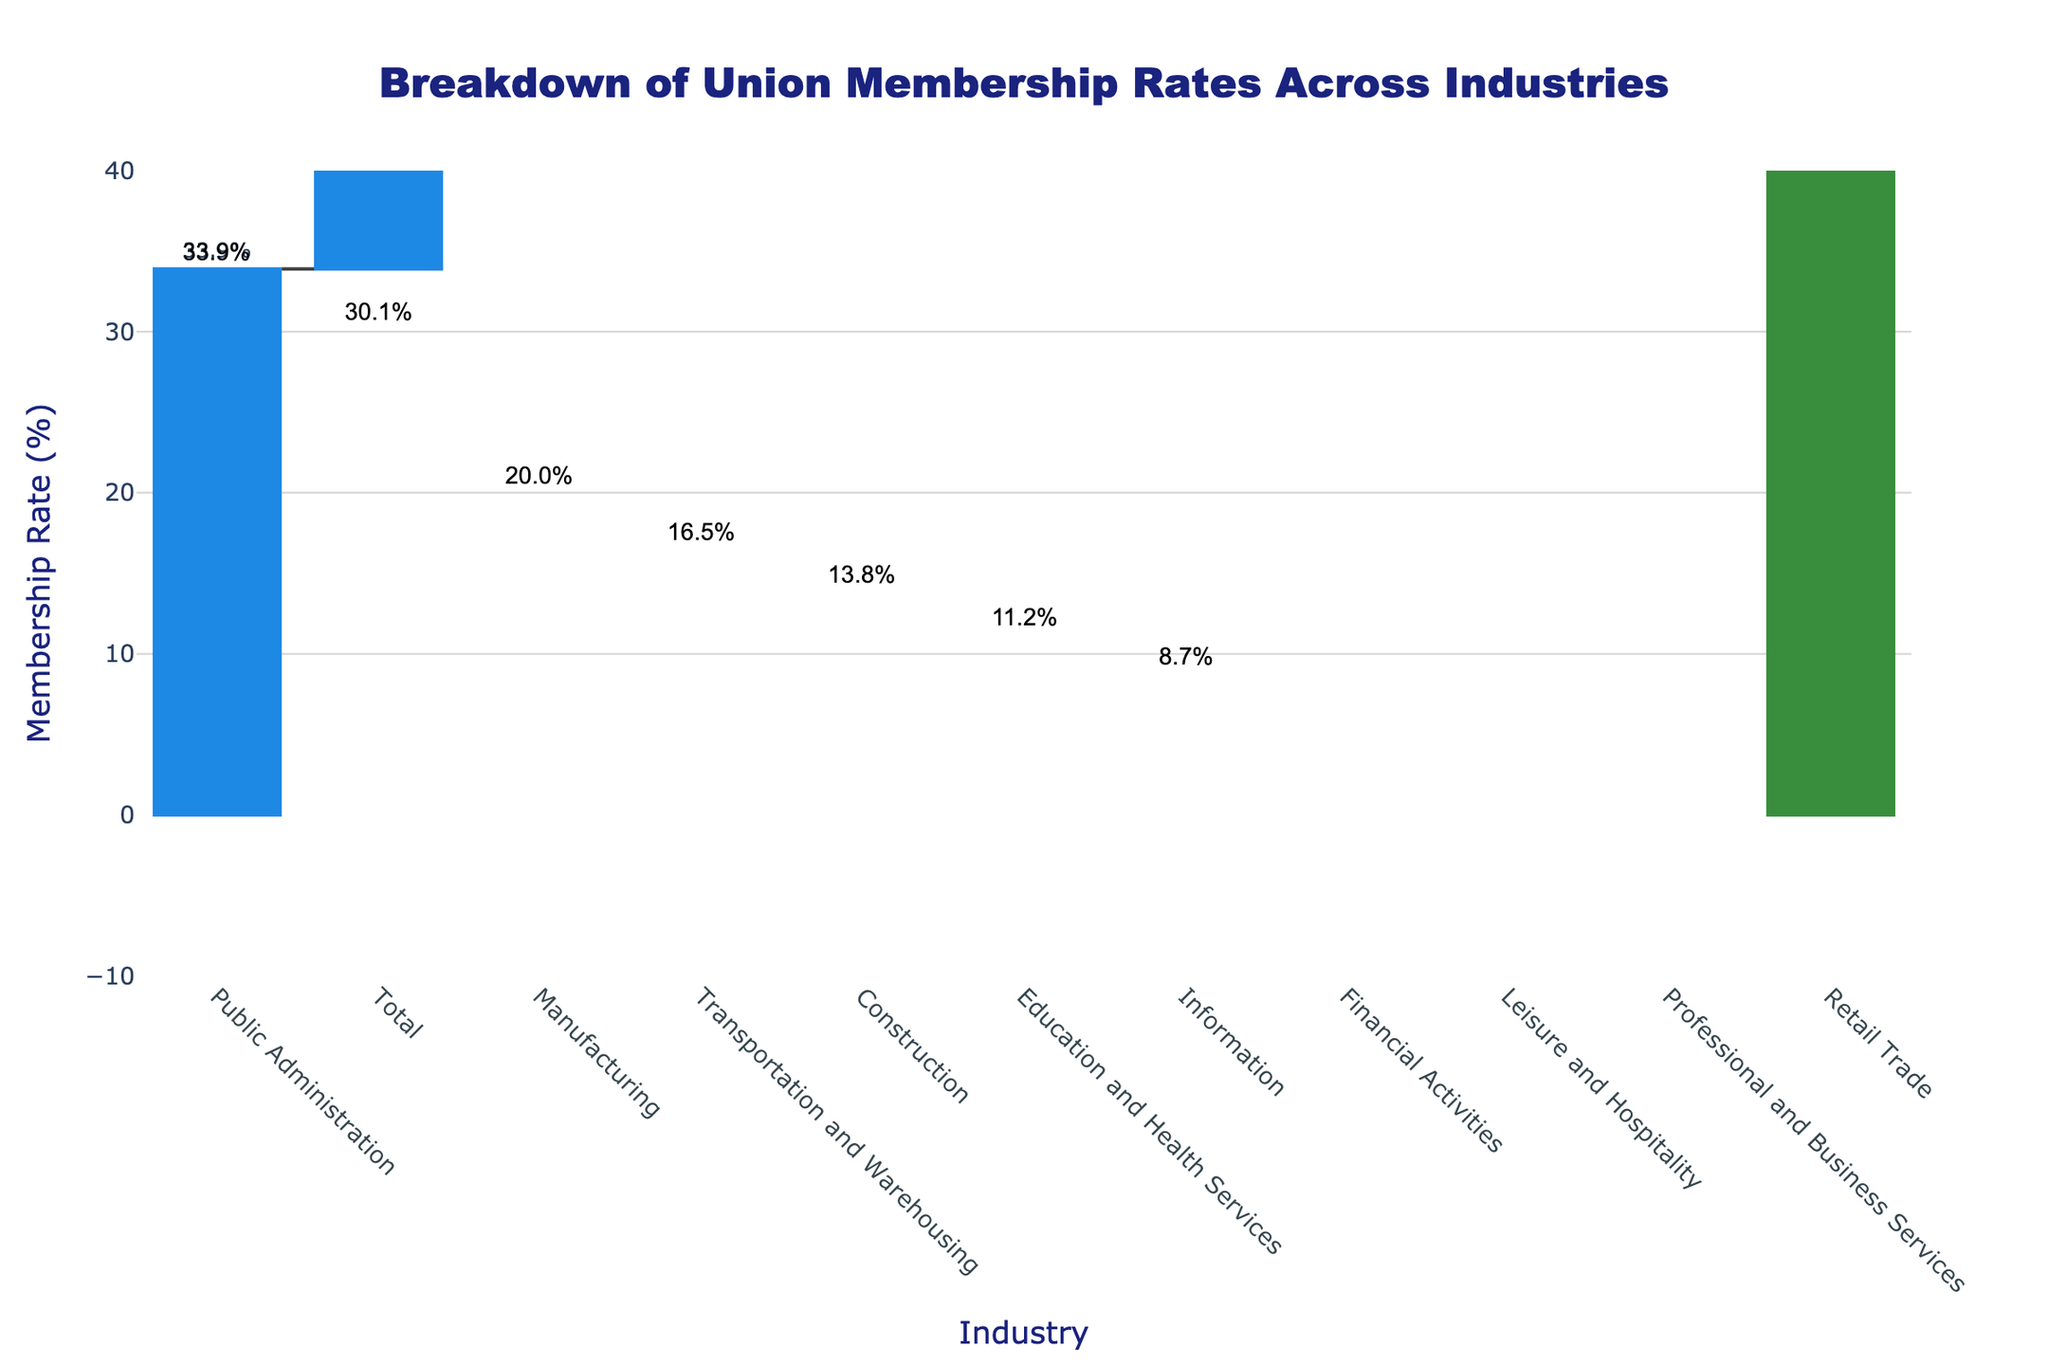What's the industry with the highest union membership rate? The industry with the highest union membership rate is the tallest blue bar, indicating the highest positive value. Public Administration has a union membership rate of 33.9%.
Answer: Public Administration Which industry has the lowest union membership rate? The industry with the lowest union membership rate is represented by the shortest red bar, indicating the most negative value. Retail Trade has a union membership rate of -5.3%.
Answer: Retail Trade What is the union membership rate for the Manufacturing industry? The exact value for the Manufacturing industry is shown on its bar. It is 20.0%.
Answer: 20.0% How does the union membership rate in Education and Health Services compare to Transportation and Warehousing? By comparing the bars for Education and Health Services and Transportation and Warehousing, Transportation and Warehousing has a higher union membership rate of 16.5% compared to 11.2% for Education and Health Services.
Answer: Transportation and Warehousing is higher What's the total union membership rate across all industries? The overall union membership rate is indicated by the final green bar. The total is 30.1%.
Answer: 30.1% What is the difference in union membership rates between Information and Construction industries? The union membership rate for Information is 8.7% and for Construction is 13.8%. The difference between them is 13.8% - 8.7% = 5.1%.
Answer: 5.1% What is the sum of union membership rates for Public Administration and Manufacturing? Add the union membership rates for Public Administration (33.9%) and Manufacturing (20.0%). The sum is 33.9% + 20.0% = 53.9%.
Answer: 53.9% Which have a negative union membership rate, and what’s their combined rate? Retail Trade (-5.3%), Professional and Business Services (-3.9%), Leisure and Hospitality (-2.1%), and Financial Activities (-1.8%) combined is -5.3% - 3.9% - 2.1% - 1.8% = -13.1%.
Answer: -13.1% How many industries have a positive union membership rate, and how many have a negative rate? Count the industries with positive rates and negative rates. Seven industries have positive rates: Manufacturing, Construction, Transportation and Warehousing, Education and Health Services, Public Administration, Information, and Total. Four industries have negative rates: Retail Trade, Professional and Business Services, Leisure and Hospitality, and Financial Activities.
Answer: 7 positive, 4 negative What is the average union membership rate of all industries except the total? Sum all individual industry rates and divide by the number of industries. The sum is 20.0 + 13.8 + 16.5 + 11.2 + 33.9 + 8.7 - 5.3 - 3.9 - 2.1 - 1.8 = 91.0%. Divided by 10 industries, the average is 91.0% / 10 = 9.1%.
Answer: 9.1% 